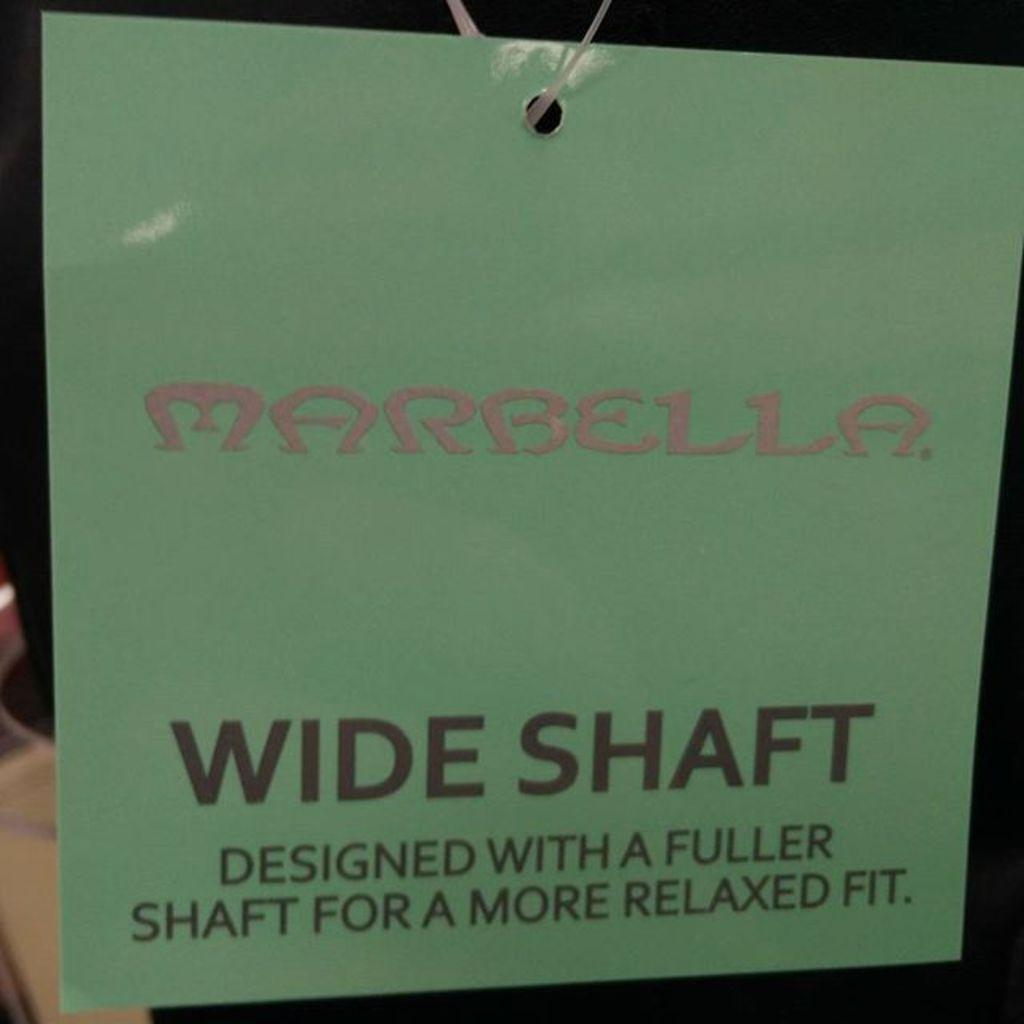<image>
Render a clear and concise summary of the photo. a wide shaft text that is on a green paper 